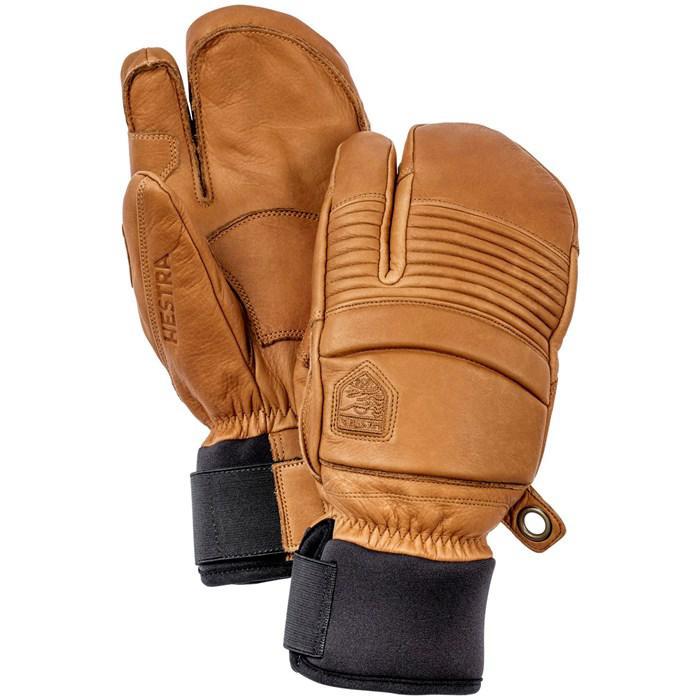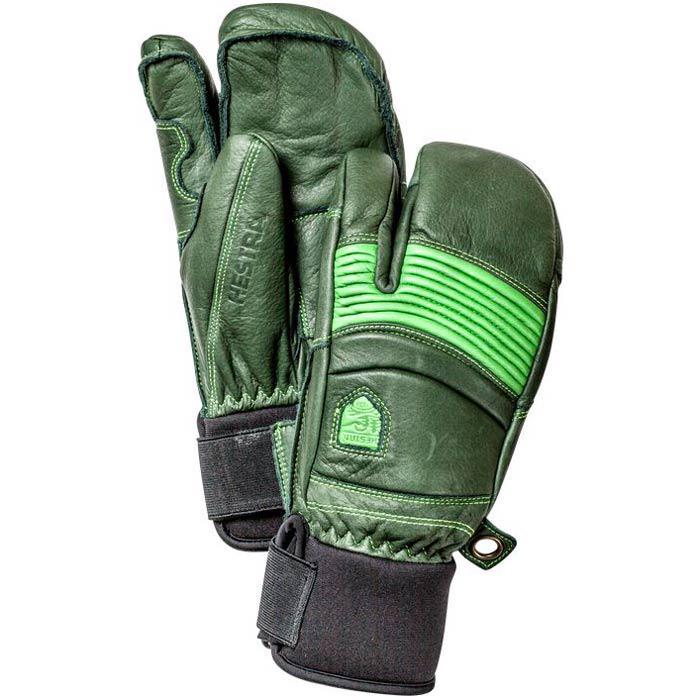The first image is the image on the left, the second image is the image on the right. Given the left and right images, does the statement "There is a pair of brown leather mittens in one of the images." hold true? Answer yes or no. Yes. The first image is the image on the left, the second image is the image on the right. Evaluate the accuracy of this statement regarding the images: "Every mitten has a white tip and palm.". Is it true? Answer yes or no. No. 